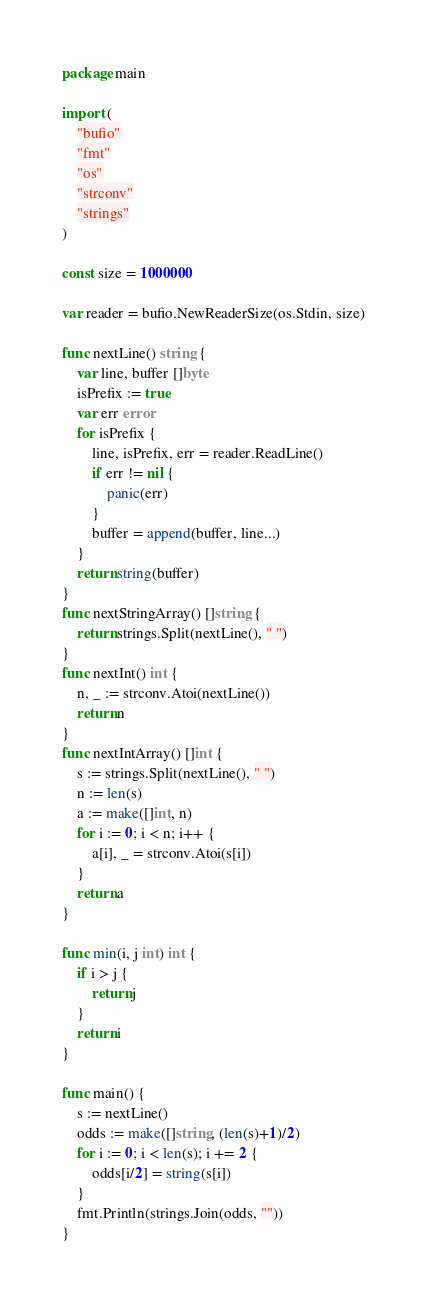Convert code to text. <code><loc_0><loc_0><loc_500><loc_500><_Go_>package main

import (
	"bufio"
	"fmt"
	"os"
	"strconv"
	"strings"
)

const size = 1000000

var reader = bufio.NewReaderSize(os.Stdin, size)

func nextLine() string {
	var line, buffer []byte
	isPrefix := true
	var err error
	for isPrefix {
		line, isPrefix, err = reader.ReadLine()
		if err != nil {
			panic(err)
		}
		buffer = append(buffer, line...)
	}
	return string(buffer)
}
func nextStringArray() []string {
	return strings.Split(nextLine(), " ")
}
func nextInt() int {
	n, _ := strconv.Atoi(nextLine())
	return n
}
func nextIntArray() []int {
	s := strings.Split(nextLine(), " ")
	n := len(s)
	a := make([]int, n)
	for i := 0; i < n; i++ {
		a[i], _ = strconv.Atoi(s[i])
	}
	return a
}

func min(i, j int) int {
	if i > j {
		return j
	}
	return i
}

func main() {
	s := nextLine()
	odds := make([]string, (len(s)+1)/2)
	for i := 0; i < len(s); i += 2 {
		odds[i/2] = string(s[i])
	}
	fmt.Println(strings.Join(odds, ""))
}
</code> 